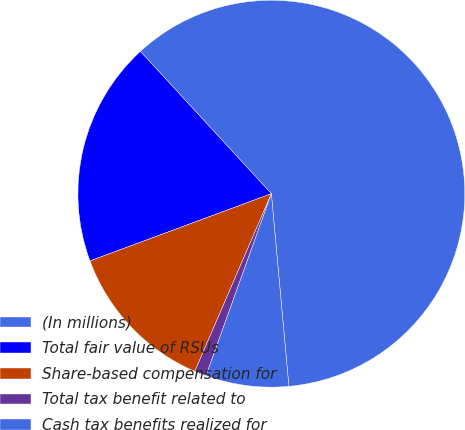Convert chart. <chart><loc_0><loc_0><loc_500><loc_500><pie_chart><fcel>(In millions)<fcel>Total fair value of RSUs<fcel>Share-based compensation for<fcel>Total tax benefit related to<fcel>Cash tax benefits realized for<nl><fcel>60.39%<fcel>18.81%<fcel>12.87%<fcel>0.99%<fcel>6.93%<nl></chart> 